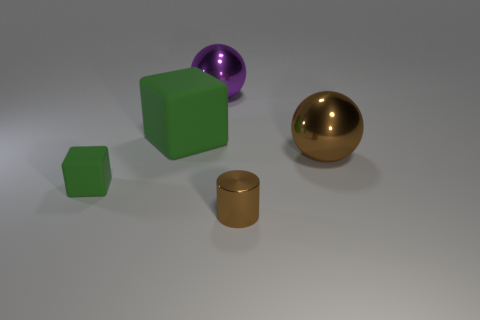What number of other things are there of the same material as the big green cube
Provide a short and direct response. 1. Is the number of large rubber blocks greater than the number of large yellow balls?
Your response must be concise. Yes. Does the shiny sphere in front of the big matte thing have the same color as the tiny metal thing?
Offer a very short reply. Yes. What is the color of the tiny rubber thing?
Offer a terse response. Green. Is there a green thing that is in front of the large metallic ball in front of the purple object?
Your answer should be compact. Yes. The green matte object in front of the large ball that is in front of the large purple shiny sphere is what shape?
Keep it short and to the point. Cube. Is the number of big purple objects less than the number of green things?
Give a very brief answer. Yes. Are the large purple ball and the large brown object made of the same material?
Your answer should be compact. Yes. What is the color of the big thing that is both in front of the purple metallic ball and left of the brown cylinder?
Keep it short and to the point. Green. Are there any cyan cylinders of the same size as the brown sphere?
Give a very brief answer. No. 